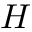<formula> <loc_0><loc_0><loc_500><loc_500>H</formula> 